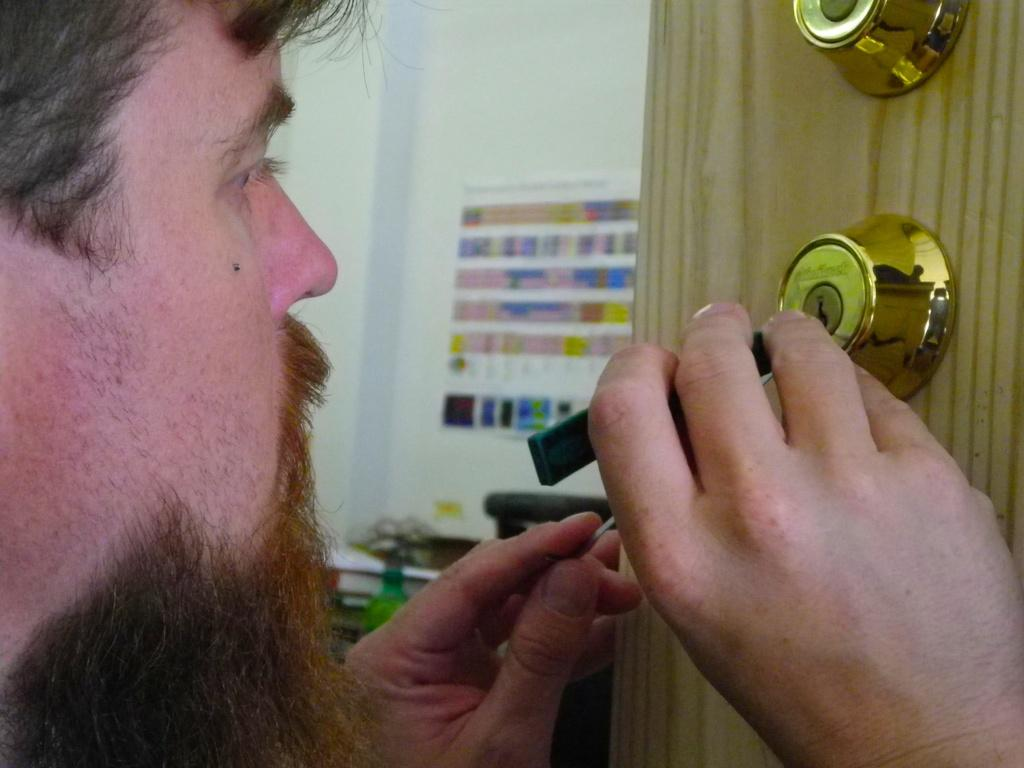What is the person in the image holding? The person is holding a tool in the image. What can be seen on the door in the image? There is a lock on the door in the image. What is attached to the wall in the image? There is a chart pasted on the wall in the image. Can you see any trail of footprints leading to the door in the image? There is no trail of footprints visible in the image. 